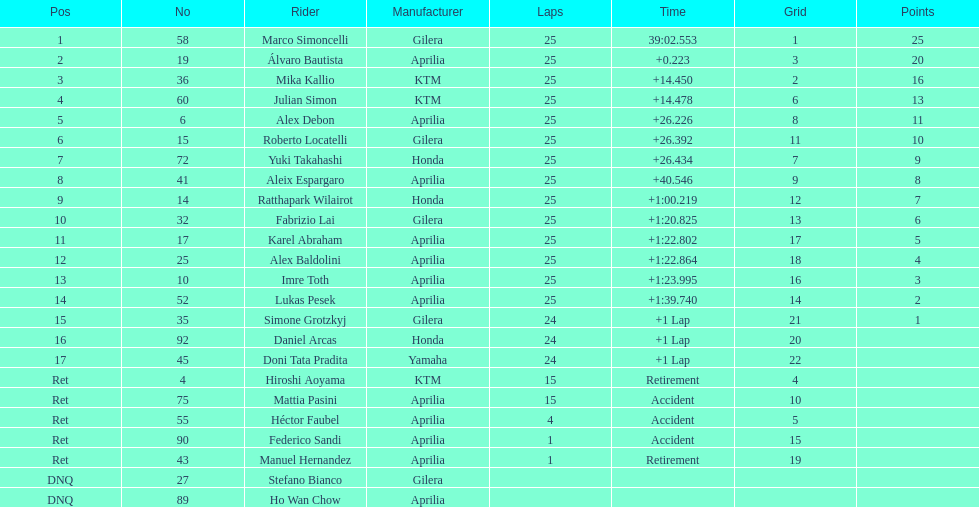Could you parse the entire table as a dict? {'header': ['Pos', 'No', 'Rider', 'Manufacturer', 'Laps', 'Time', 'Grid', 'Points'], 'rows': [['1', '58', 'Marco Simoncelli', 'Gilera', '25', '39:02.553', '1', '25'], ['2', '19', 'Álvaro Bautista', 'Aprilia', '25', '+0.223', '3', '20'], ['3', '36', 'Mika Kallio', 'KTM', '25', '+14.450', '2', '16'], ['4', '60', 'Julian Simon', 'KTM', '25', '+14.478', '6', '13'], ['5', '6', 'Alex Debon', 'Aprilia', '25', '+26.226', '8', '11'], ['6', '15', 'Roberto Locatelli', 'Gilera', '25', '+26.392', '11', '10'], ['7', '72', 'Yuki Takahashi', 'Honda', '25', '+26.434', '7', '9'], ['8', '41', 'Aleix Espargaro', 'Aprilia', '25', '+40.546', '9', '8'], ['9', '14', 'Ratthapark Wilairot', 'Honda', '25', '+1:00.219', '12', '7'], ['10', '32', 'Fabrizio Lai', 'Gilera', '25', '+1:20.825', '13', '6'], ['11', '17', 'Karel Abraham', 'Aprilia', '25', '+1:22.802', '17', '5'], ['12', '25', 'Alex Baldolini', 'Aprilia', '25', '+1:22.864', '18', '4'], ['13', '10', 'Imre Toth', 'Aprilia', '25', '+1:23.995', '16', '3'], ['14', '52', 'Lukas Pesek', 'Aprilia', '25', '+1:39.740', '14', '2'], ['15', '35', 'Simone Grotzkyj', 'Gilera', '24', '+1 Lap', '21', '1'], ['16', '92', 'Daniel Arcas', 'Honda', '24', '+1 Lap', '20', ''], ['17', '45', 'Doni Tata Pradita', 'Yamaha', '24', '+1 Lap', '22', ''], ['Ret', '4', 'Hiroshi Aoyama', 'KTM', '15', 'Retirement', '4', ''], ['Ret', '75', 'Mattia Pasini', 'Aprilia', '15', 'Accident', '10', ''], ['Ret', '55', 'Héctor Faubel', 'Aprilia', '4', 'Accident', '5', ''], ['Ret', '90', 'Federico Sandi', 'Aprilia', '1', 'Accident', '15', ''], ['Ret', '43', 'Manuel Hernandez', 'Aprilia', '1', 'Retirement', '19', ''], ['DNQ', '27', 'Stefano Bianco', 'Gilera', '', '', '', ''], ['DNQ', '89', 'Ho Wan Chow', 'Aprilia', '', '', '', '']]} What is the total number of rider? 24. 